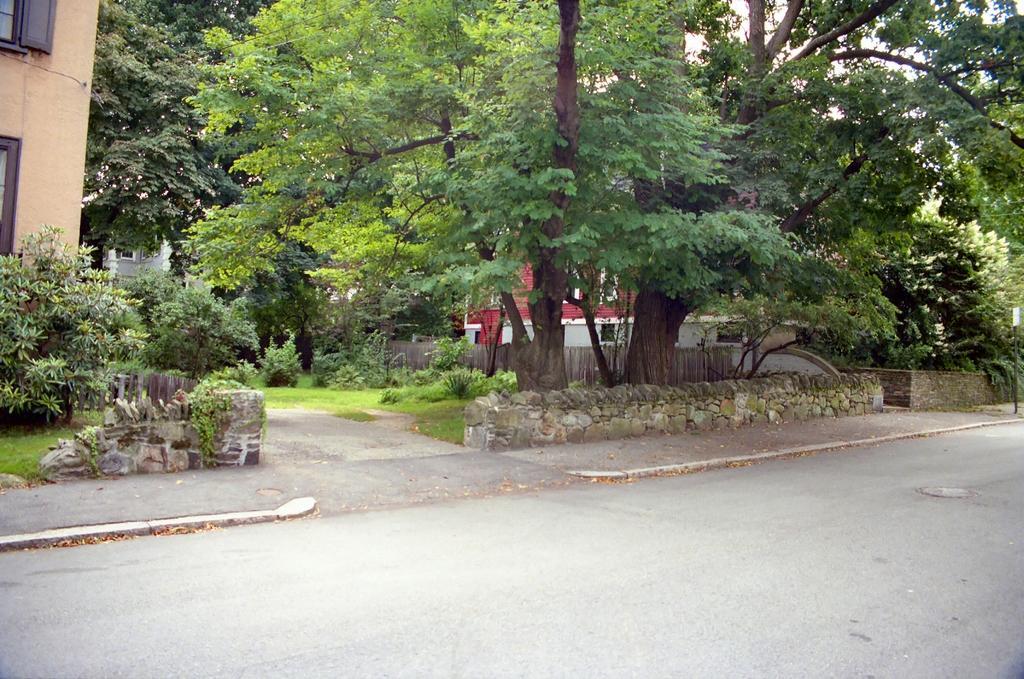Can you describe this image briefly? This is road. Here we can see plants, grass, trees, wall, and buildings. 